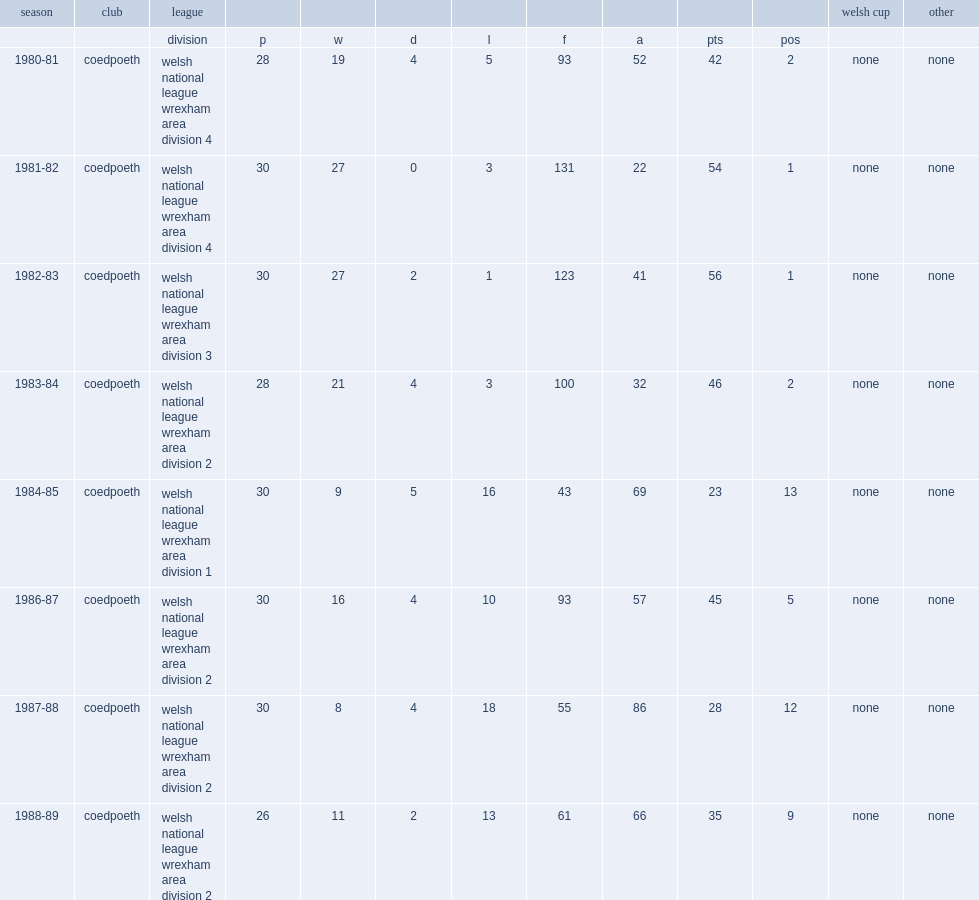Can you parse all the data within this table? {'header': ['season', 'club', 'league', '', '', '', '', '', '', '', '', 'welsh cup', 'other'], 'rows': [['', '', 'division', 'p', 'w', 'd', 'l', 'f', 'a', 'pts', 'pos', '', ''], ['1980-81', 'coedpoeth', 'welsh national league wrexham area division 4', '28', '19', '4', '5', '93', '52', '42', '2', 'none', 'none'], ['1981-82', 'coedpoeth', 'welsh national league wrexham area division 4', '30', '27', '0', '3', '131', '22', '54', '1', 'none', 'none'], ['1982-83', 'coedpoeth', 'welsh national league wrexham area division 3', '30', '27', '2', '1', '123', '41', '56', '1', 'none', 'none'], ['1983-84', 'coedpoeth', 'welsh national league wrexham area division 2', '28', '21', '4', '3', '100', '32', '46', '2', 'none', 'none'], ['1984-85', 'coedpoeth', 'welsh national league wrexham area division 1', '30', '9', '5', '16', '43', '69', '23', '13', 'none', 'none'], ['1986-87', 'coedpoeth', 'welsh national league wrexham area division 2', '30', '16', '4', '10', '93', '57', '45', '5', 'none', 'none'], ['1987-88', 'coedpoeth', 'welsh national league wrexham area division 2', '30', '8', '4', '18', '55', '86', '28', '12', 'none', 'none'], ['1988-89', 'coedpoeth', 'welsh national league wrexham area division 2', '26', '11', '2', '13', '61', '66', '35', '9', 'none', 'none']]} What was the rank that coedpoeth finished in the 1980-81 season? 2.0. 